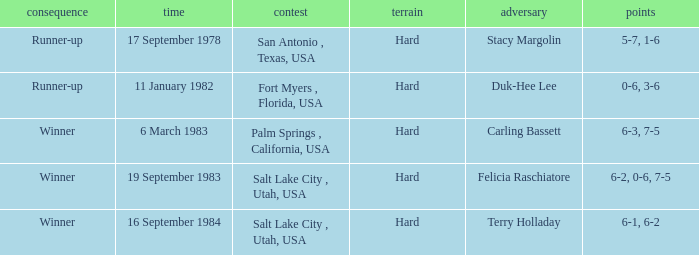Who was the opponent for the match were the outcome was runner-up and the score was 5-7, 1-6? Stacy Margolin. 